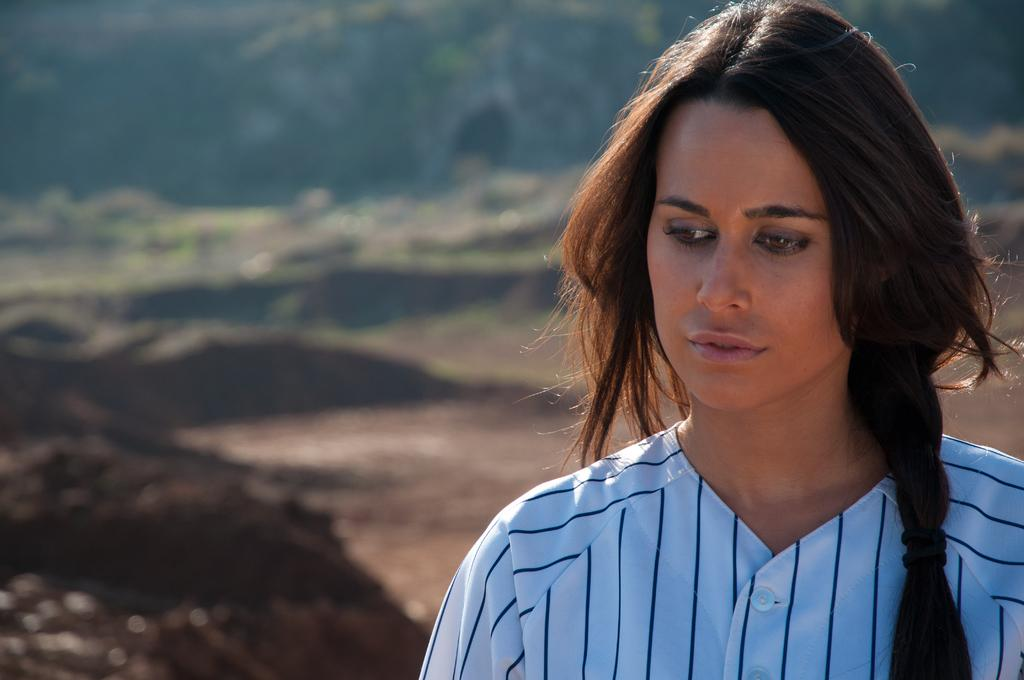Who is present in the image? There is a girl in the image. Where is the girl located in the image? The girl is in the right corner of the image. What is the girl wearing? The girl is wearing a white shirt. What is the girl's posture in the image? The girl is standing. What type of soil can be seen beside the girl? There is black soil beside the girl. What can be seen in the background of the image? There are trees visible in the background of the image. How is the background of the image depicted? The background is blurred. What type of chin can be seen on the donkey in the image? There is no donkey present in the image, so it is not possible to answer that question. 